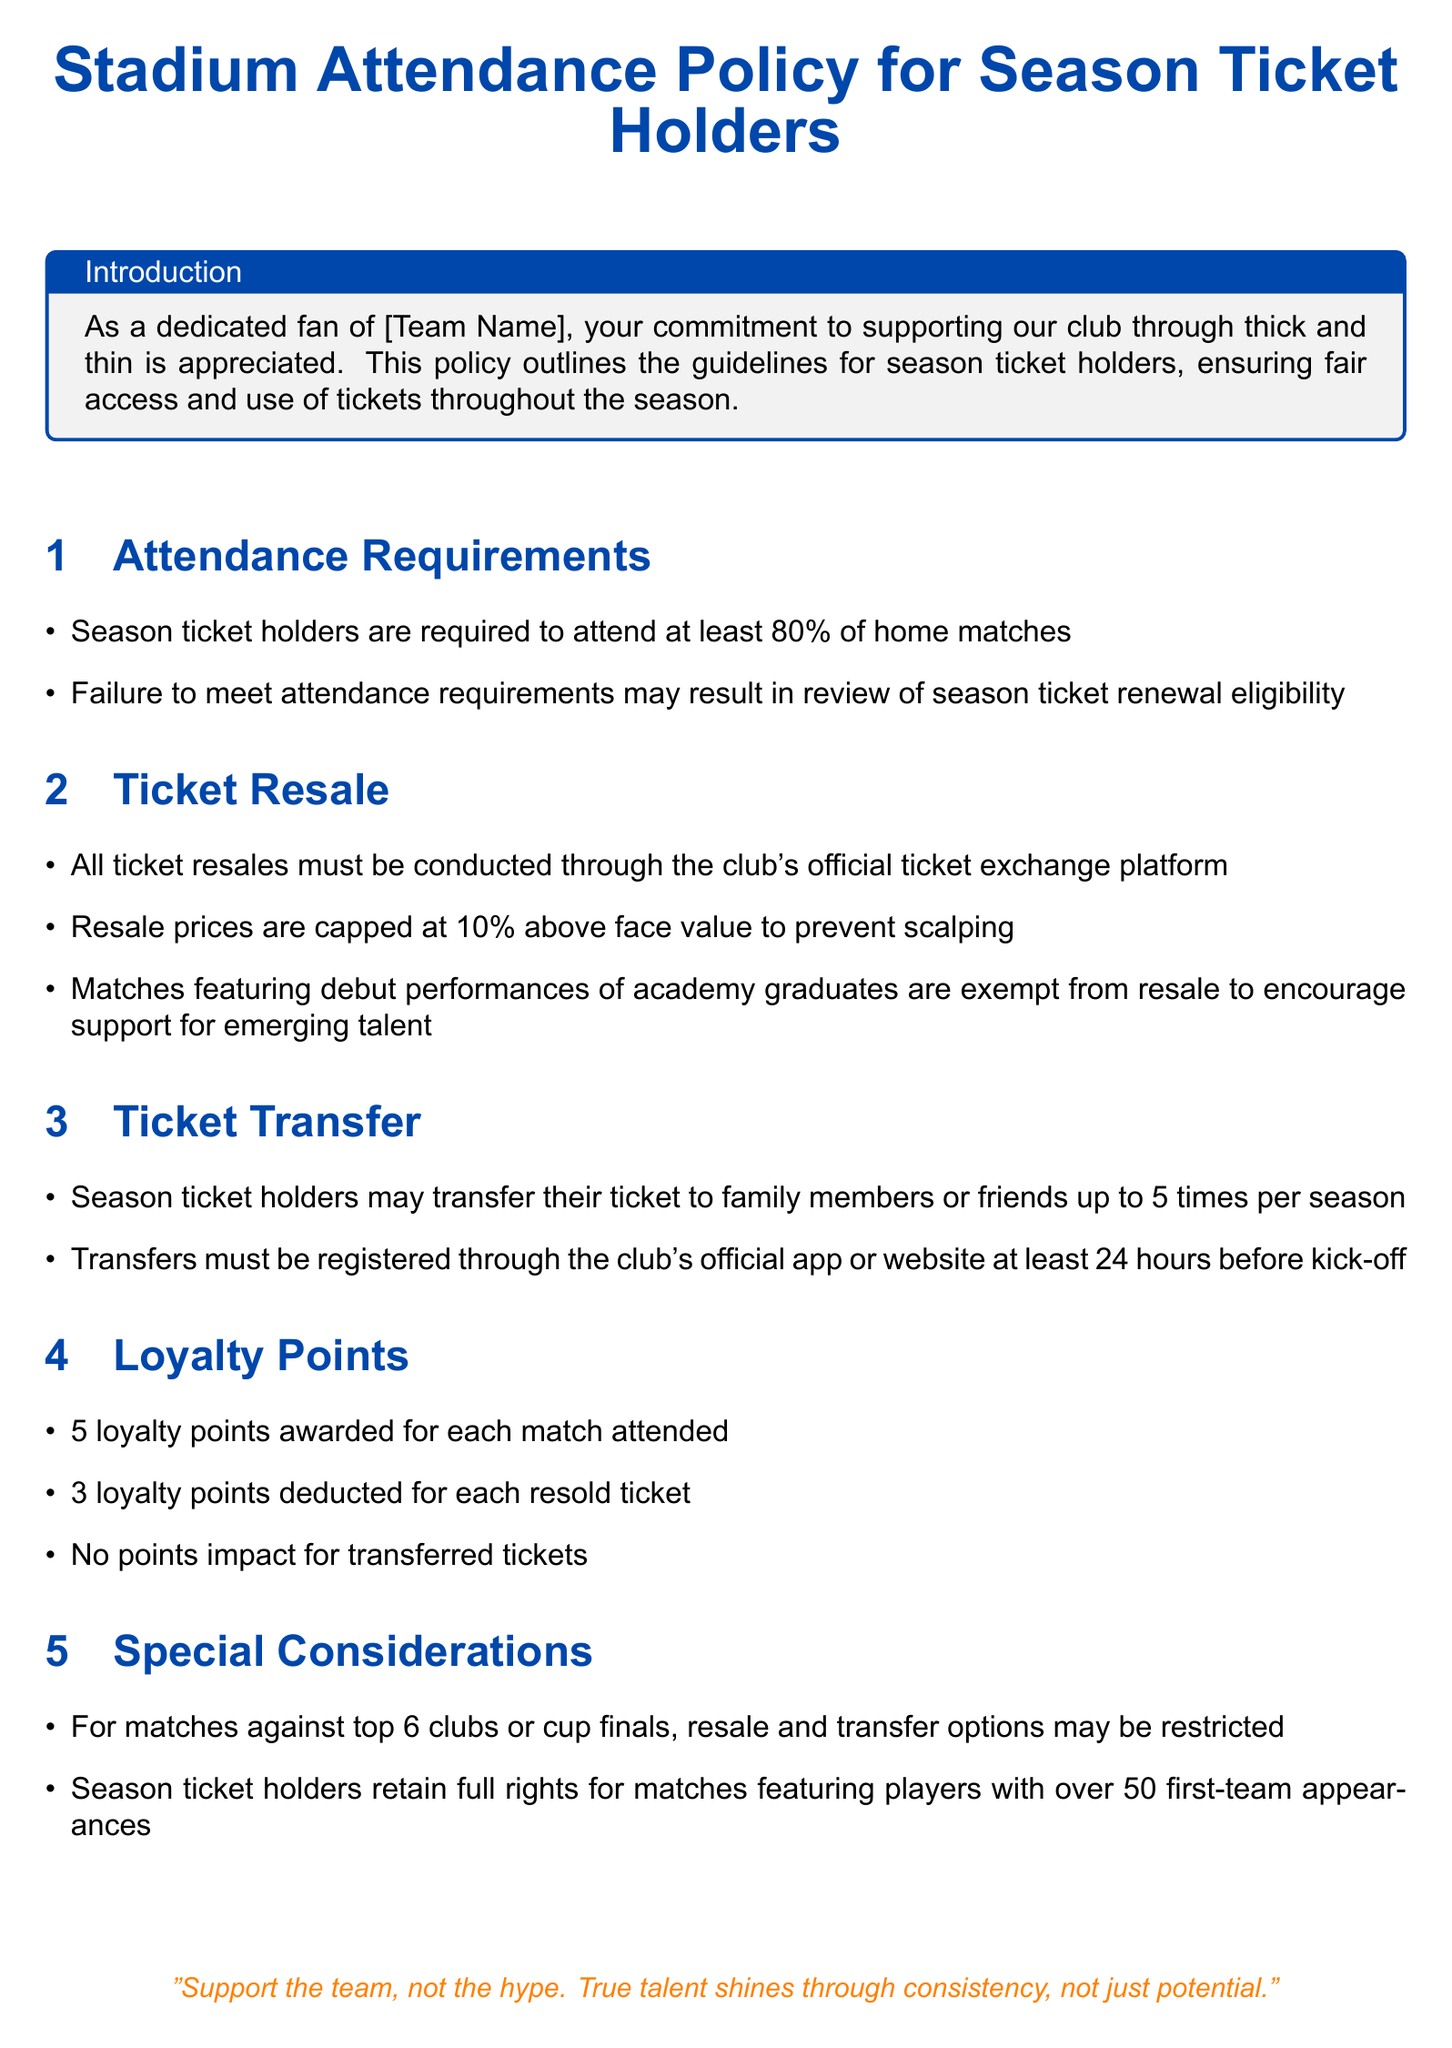What percentage of home matches must season ticket holders attend? The document states that season ticket holders are required to attend at least 80% of home matches.
Answer: 80% What is the resale price cap for tickets? The policy specifies that resale prices are capped at 10% above face value.
Answer: 10% How many times can tickets be transferred in a season? According to the policy, season ticket holders may transfer their ticket up to 5 times per season.
Answer: 5 times What is the loyalty points awarded for attending each match? The document mentions that 5 loyalty points are awarded for each match attended.
Answer: 5 points What must be done 24 hours before kick-off for ticket transfers? The policy requires that transfers must be registered through the club's official app or website at least 24 hours before kick-off.
Answer: Registered Which matches feature resale and transfer restrictions? The document indicates that matches against top 6 clubs or cup finals may have resale and transfer restrictions.
Answer: Top 6 clubs or cup finals What happens if attendance requirements are not met? The document states that failure to meet attendance requirements may result in review of season ticket renewal eligibility.
Answer: Review eligibility 